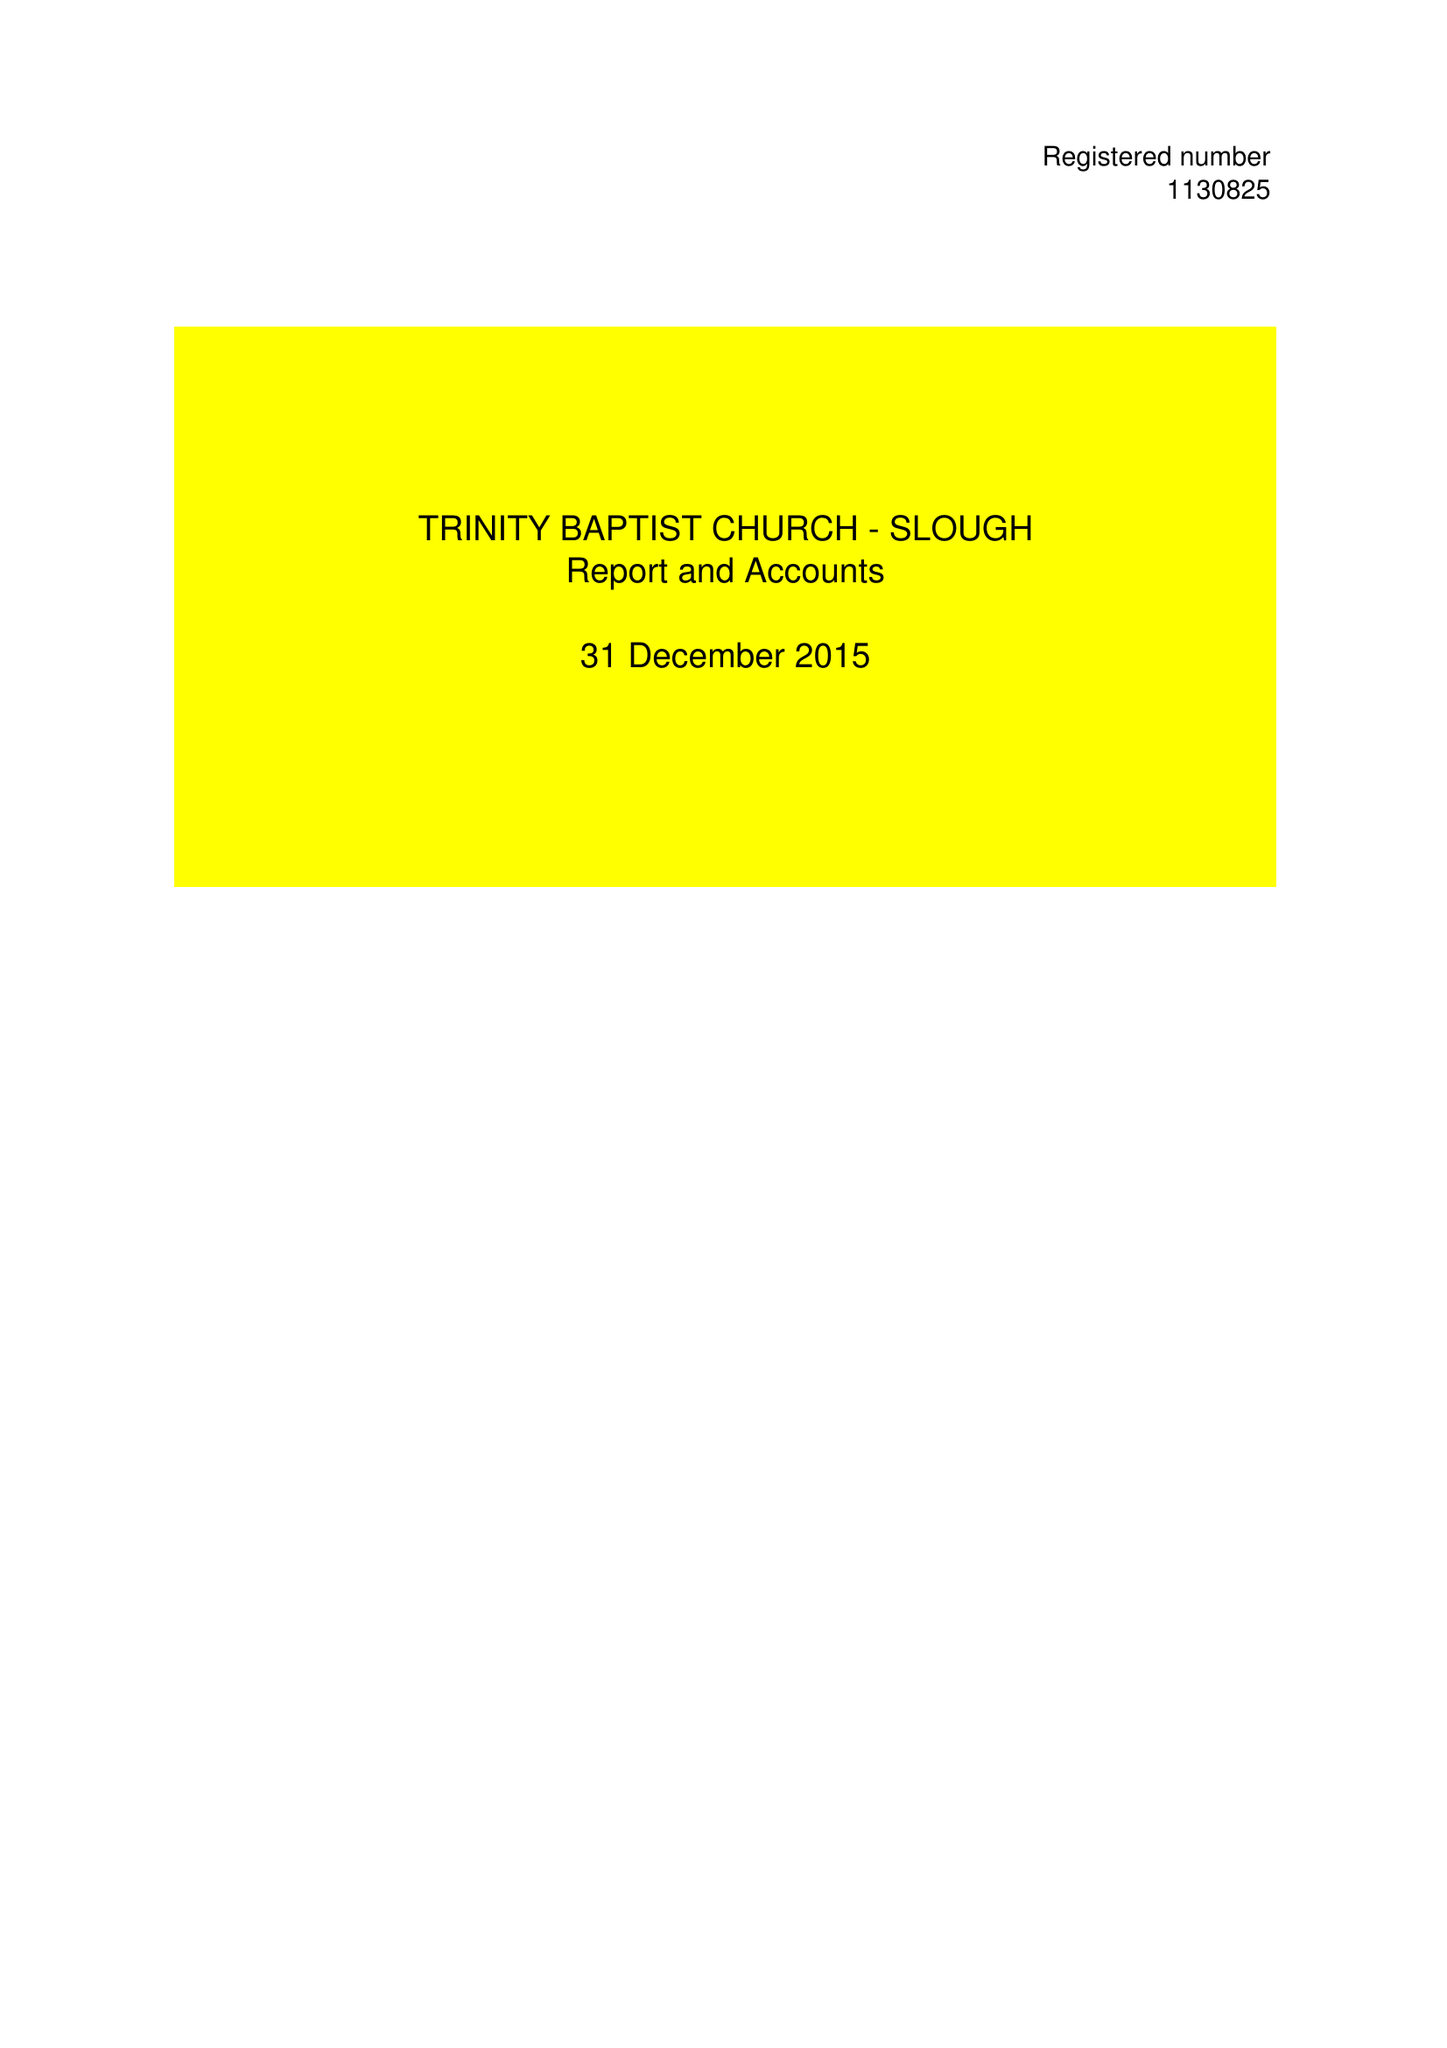What is the value for the address__post_town?
Answer the question using a single word or phrase. MITCHAM 